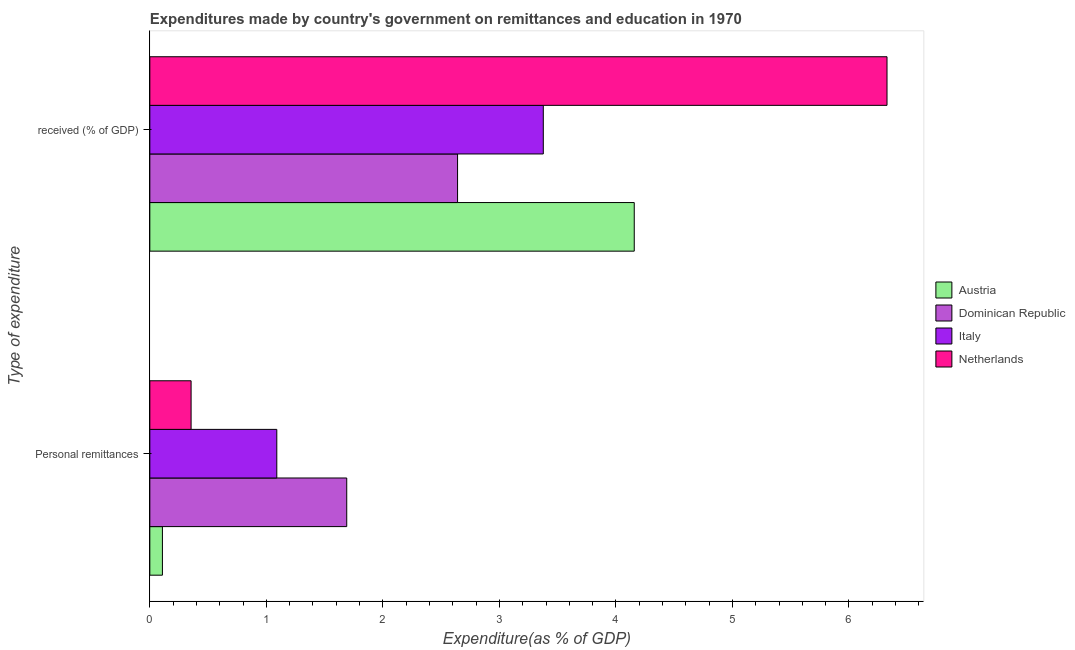How many bars are there on the 2nd tick from the top?
Give a very brief answer. 4. How many bars are there on the 2nd tick from the bottom?
Provide a succinct answer. 4. What is the label of the 1st group of bars from the top?
Your answer should be very brief.  received (% of GDP). What is the expenditure in personal remittances in Austria?
Ensure brevity in your answer.  0.11. Across all countries, what is the maximum expenditure in education?
Keep it short and to the point. 6.33. Across all countries, what is the minimum expenditure in personal remittances?
Keep it short and to the point. 0.11. In which country was the expenditure in personal remittances maximum?
Provide a short and direct response. Dominican Republic. In which country was the expenditure in education minimum?
Make the answer very short. Dominican Republic. What is the total expenditure in personal remittances in the graph?
Your answer should be compact. 3.24. What is the difference between the expenditure in education in Italy and that in Netherlands?
Ensure brevity in your answer.  -2.95. What is the difference between the expenditure in education in Dominican Republic and the expenditure in personal remittances in Netherlands?
Provide a short and direct response. 2.29. What is the average expenditure in education per country?
Your answer should be very brief. 4.13. What is the difference between the expenditure in personal remittances and expenditure in education in Dominican Republic?
Offer a terse response. -0.95. What is the ratio of the expenditure in education in Austria to that in Dominican Republic?
Your answer should be very brief. 1.57. In how many countries, is the expenditure in personal remittances greater than the average expenditure in personal remittances taken over all countries?
Your answer should be very brief. 2. What does the 2nd bar from the bottom in Personal remittances represents?
Ensure brevity in your answer.  Dominican Republic. How many bars are there?
Your answer should be very brief. 8. How many countries are there in the graph?
Your response must be concise. 4. What is the difference between two consecutive major ticks on the X-axis?
Provide a short and direct response. 1. Are the values on the major ticks of X-axis written in scientific E-notation?
Your answer should be compact. No. Does the graph contain any zero values?
Provide a short and direct response. No. What is the title of the graph?
Ensure brevity in your answer.  Expenditures made by country's government on remittances and education in 1970. Does "Tunisia" appear as one of the legend labels in the graph?
Your response must be concise. No. What is the label or title of the X-axis?
Your answer should be very brief. Expenditure(as % of GDP). What is the label or title of the Y-axis?
Provide a short and direct response. Type of expenditure. What is the Expenditure(as % of GDP) of Austria in Personal remittances?
Make the answer very short. 0.11. What is the Expenditure(as % of GDP) in Dominican Republic in Personal remittances?
Provide a short and direct response. 1.69. What is the Expenditure(as % of GDP) of Italy in Personal remittances?
Offer a very short reply. 1.09. What is the Expenditure(as % of GDP) in Netherlands in Personal remittances?
Provide a succinct answer. 0.35. What is the Expenditure(as % of GDP) of Austria in  received (% of GDP)?
Your response must be concise. 4.16. What is the Expenditure(as % of GDP) of Dominican Republic in  received (% of GDP)?
Offer a very short reply. 2.64. What is the Expenditure(as % of GDP) in Italy in  received (% of GDP)?
Make the answer very short. 3.38. What is the Expenditure(as % of GDP) in Netherlands in  received (% of GDP)?
Ensure brevity in your answer.  6.33. Across all Type of expenditure, what is the maximum Expenditure(as % of GDP) in Austria?
Your response must be concise. 4.16. Across all Type of expenditure, what is the maximum Expenditure(as % of GDP) in Dominican Republic?
Your answer should be compact. 2.64. Across all Type of expenditure, what is the maximum Expenditure(as % of GDP) in Italy?
Your answer should be compact. 3.38. Across all Type of expenditure, what is the maximum Expenditure(as % of GDP) in Netherlands?
Make the answer very short. 6.33. Across all Type of expenditure, what is the minimum Expenditure(as % of GDP) of Austria?
Give a very brief answer. 0.11. Across all Type of expenditure, what is the minimum Expenditure(as % of GDP) in Dominican Republic?
Provide a succinct answer. 1.69. Across all Type of expenditure, what is the minimum Expenditure(as % of GDP) in Italy?
Make the answer very short. 1.09. Across all Type of expenditure, what is the minimum Expenditure(as % of GDP) in Netherlands?
Make the answer very short. 0.35. What is the total Expenditure(as % of GDP) in Austria in the graph?
Your response must be concise. 4.27. What is the total Expenditure(as % of GDP) in Dominican Republic in the graph?
Offer a very short reply. 4.33. What is the total Expenditure(as % of GDP) of Italy in the graph?
Offer a very short reply. 4.47. What is the total Expenditure(as % of GDP) in Netherlands in the graph?
Keep it short and to the point. 6.68. What is the difference between the Expenditure(as % of GDP) of Austria in Personal remittances and that in  received (% of GDP)?
Give a very brief answer. -4.05. What is the difference between the Expenditure(as % of GDP) of Dominican Republic in Personal remittances and that in  received (% of GDP)?
Provide a short and direct response. -0.95. What is the difference between the Expenditure(as % of GDP) in Italy in Personal remittances and that in  received (% of GDP)?
Your response must be concise. -2.29. What is the difference between the Expenditure(as % of GDP) in Netherlands in Personal remittances and that in  received (% of GDP)?
Give a very brief answer. -5.97. What is the difference between the Expenditure(as % of GDP) of Austria in Personal remittances and the Expenditure(as % of GDP) of Dominican Republic in  received (% of GDP)?
Your answer should be compact. -2.53. What is the difference between the Expenditure(as % of GDP) of Austria in Personal remittances and the Expenditure(as % of GDP) of Italy in  received (% of GDP)?
Keep it short and to the point. -3.27. What is the difference between the Expenditure(as % of GDP) in Austria in Personal remittances and the Expenditure(as % of GDP) in Netherlands in  received (% of GDP)?
Ensure brevity in your answer.  -6.22. What is the difference between the Expenditure(as % of GDP) of Dominican Republic in Personal remittances and the Expenditure(as % of GDP) of Italy in  received (% of GDP)?
Provide a short and direct response. -1.69. What is the difference between the Expenditure(as % of GDP) in Dominican Republic in Personal remittances and the Expenditure(as % of GDP) in Netherlands in  received (% of GDP)?
Your answer should be compact. -4.64. What is the difference between the Expenditure(as % of GDP) in Italy in Personal remittances and the Expenditure(as % of GDP) in Netherlands in  received (% of GDP)?
Make the answer very short. -5.24. What is the average Expenditure(as % of GDP) in Austria per Type of expenditure?
Your answer should be compact. 2.13. What is the average Expenditure(as % of GDP) of Dominican Republic per Type of expenditure?
Your response must be concise. 2.17. What is the average Expenditure(as % of GDP) of Italy per Type of expenditure?
Ensure brevity in your answer.  2.23. What is the average Expenditure(as % of GDP) of Netherlands per Type of expenditure?
Your answer should be compact. 3.34. What is the difference between the Expenditure(as % of GDP) of Austria and Expenditure(as % of GDP) of Dominican Republic in Personal remittances?
Provide a succinct answer. -1.58. What is the difference between the Expenditure(as % of GDP) in Austria and Expenditure(as % of GDP) in Italy in Personal remittances?
Offer a terse response. -0.98. What is the difference between the Expenditure(as % of GDP) of Austria and Expenditure(as % of GDP) of Netherlands in Personal remittances?
Make the answer very short. -0.25. What is the difference between the Expenditure(as % of GDP) of Dominican Republic and Expenditure(as % of GDP) of Italy in Personal remittances?
Give a very brief answer. 0.6. What is the difference between the Expenditure(as % of GDP) of Dominican Republic and Expenditure(as % of GDP) of Netherlands in Personal remittances?
Give a very brief answer. 1.34. What is the difference between the Expenditure(as % of GDP) of Italy and Expenditure(as % of GDP) of Netherlands in Personal remittances?
Keep it short and to the point. 0.74. What is the difference between the Expenditure(as % of GDP) in Austria and Expenditure(as % of GDP) in Dominican Republic in  received (% of GDP)?
Offer a very short reply. 1.52. What is the difference between the Expenditure(as % of GDP) of Austria and Expenditure(as % of GDP) of Italy in  received (% of GDP)?
Offer a very short reply. 0.78. What is the difference between the Expenditure(as % of GDP) of Austria and Expenditure(as % of GDP) of Netherlands in  received (% of GDP)?
Your answer should be compact. -2.17. What is the difference between the Expenditure(as % of GDP) of Dominican Republic and Expenditure(as % of GDP) of Italy in  received (% of GDP)?
Give a very brief answer. -0.74. What is the difference between the Expenditure(as % of GDP) of Dominican Republic and Expenditure(as % of GDP) of Netherlands in  received (% of GDP)?
Provide a short and direct response. -3.69. What is the difference between the Expenditure(as % of GDP) in Italy and Expenditure(as % of GDP) in Netherlands in  received (% of GDP)?
Give a very brief answer. -2.95. What is the ratio of the Expenditure(as % of GDP) of Austria in Personal remittances to that in  received (% of GDP)?
Ensure brevity in your answer.  0.03. What is the ratio of the Expenditure(as % of GDP) in Dominican Republic in Personal remittances to that in  received (% of GDP)?
Provide a succinct answer. 0.64. What is the ratio of the Expenditure(as % of GDP) of Italy in Personal remittances to that in  received (% of GDP)?
Your answer should be very brief. 0.32. What is the ratio of the Expenditure(as % of GDP) in Netherlands in Personal remittances to that in  received (% of GDP)?
Offer a terse response. 0.06. What is the difference between the highest and the second highest Expenditure(as % of GDP) in Austria?
Ensure brevity in your answer.  4.05. What is the difference between the highest and the second highest Expenditure(as % of GDP) in Dominican Republic?
Offer a terse response. 0.95. What is the difference between the highest and the second highest Expenditure(as % of GDP) in Italy?
Provide a short and direct response. 2.29. What is the difference between the highest and the second highest Expenditure(as % of GDP) in Netherlands?
Keep it short and to the point. 5.97. What is the difference between the highest and the lowest Expenditure(as % of GDP) in Austria?
Make the answer very short. 4.05. What is the difference between the highest and the lowest Expenditure(as % of GDP) in Dominican Republic?
Your response must be concise. 0.95. What is the difference between the highest and the lowest Expenditure(as % of GDP) of Italy?
Offer a very short reply. 2.29. What is the difference between the highest and the lowest Expenditure(as % of GDP) in Netherlands?
Offer a very short reply. 5.97. 